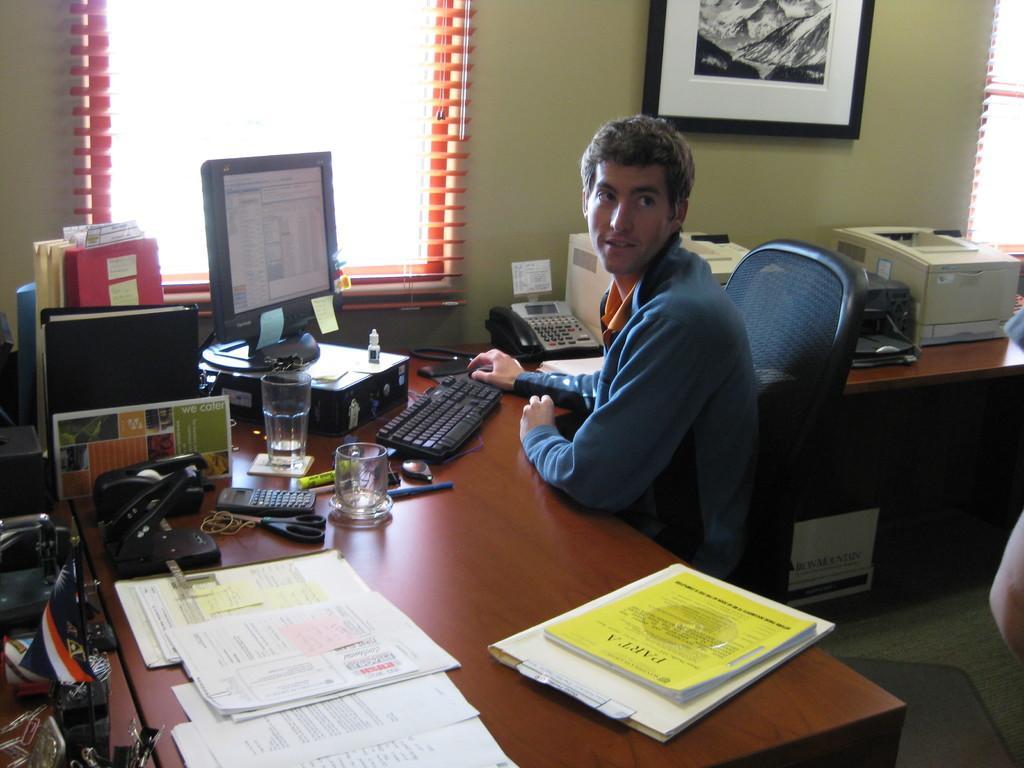Please provide a concise description of this image. In this picture we can see a man sitting on a chair and smiling, table with papers, writing pad, book, calculator, scissors, glasses, monitor, keyboard, mouse, telephone, printers on it and in the background we can see windows and a frame on the wall. 